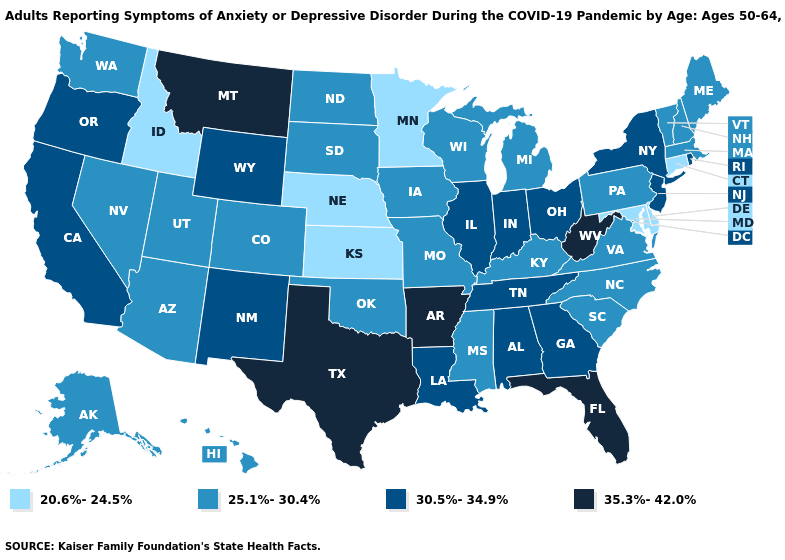What is the value of Montana?
Give a very brief answer. 35.3%-42.0%. Among the states that border Oklahoma , does Missouri have the highest value?
Be succinct. No. Among the states that border Arkansas , does Texas have the lowest value?
Be succinct. No. Among the states that border Minnesota , which have the lowest value?
Short answer required. Iowa, North Dakota, South Dakota, Wisconsin. Does New Jersey have the highest value in the USA?
Quick response, please. No. Name the states that have a value in the range 20.6%-24.5%?
Answer briefly. Connecticut, Delaware, Idaho, Kansas, Maryland, Minnesota, Nebraska. Does New Hampshire have a higher value than Idaho?
Write a very short answer. Yes. Does Alabama have the highest value in the USA?
Answer briefly. No. Among the states that border Illinois , does Indiana have the lowest value?
Be succinct. No. Name the states that have a value in the range 35.3%-42.0%?
Short answer required. Arkansas, Florida, Montana, Texas, West Virginia. What is the value of Arizona?
Answer briefly. 25.1%-30.4%. Does North Dakota have the highest value in the MidWest?
Answer briefly. No. Name the states that have a value in the range 25.1%-30.4%?
Write a very short answer. Alaska, Arizona, Colorado, Hawaii, Iowa, Kentucky, Maine, Massachusetts, Michigan, Mississippi, Missouri, Nevada, New Hampshire, North Carolina, North Dakota, Oklahoma, Pennsylvania, South Carolina, South Dakota, Utah, Vermont, Virginia, Washington, Wisconsin. What is the value of Wyoming?
Short answer required. 30.5%-34.9%. Does Delaware have the lowest value in the South?
Short answer required. Yes. 